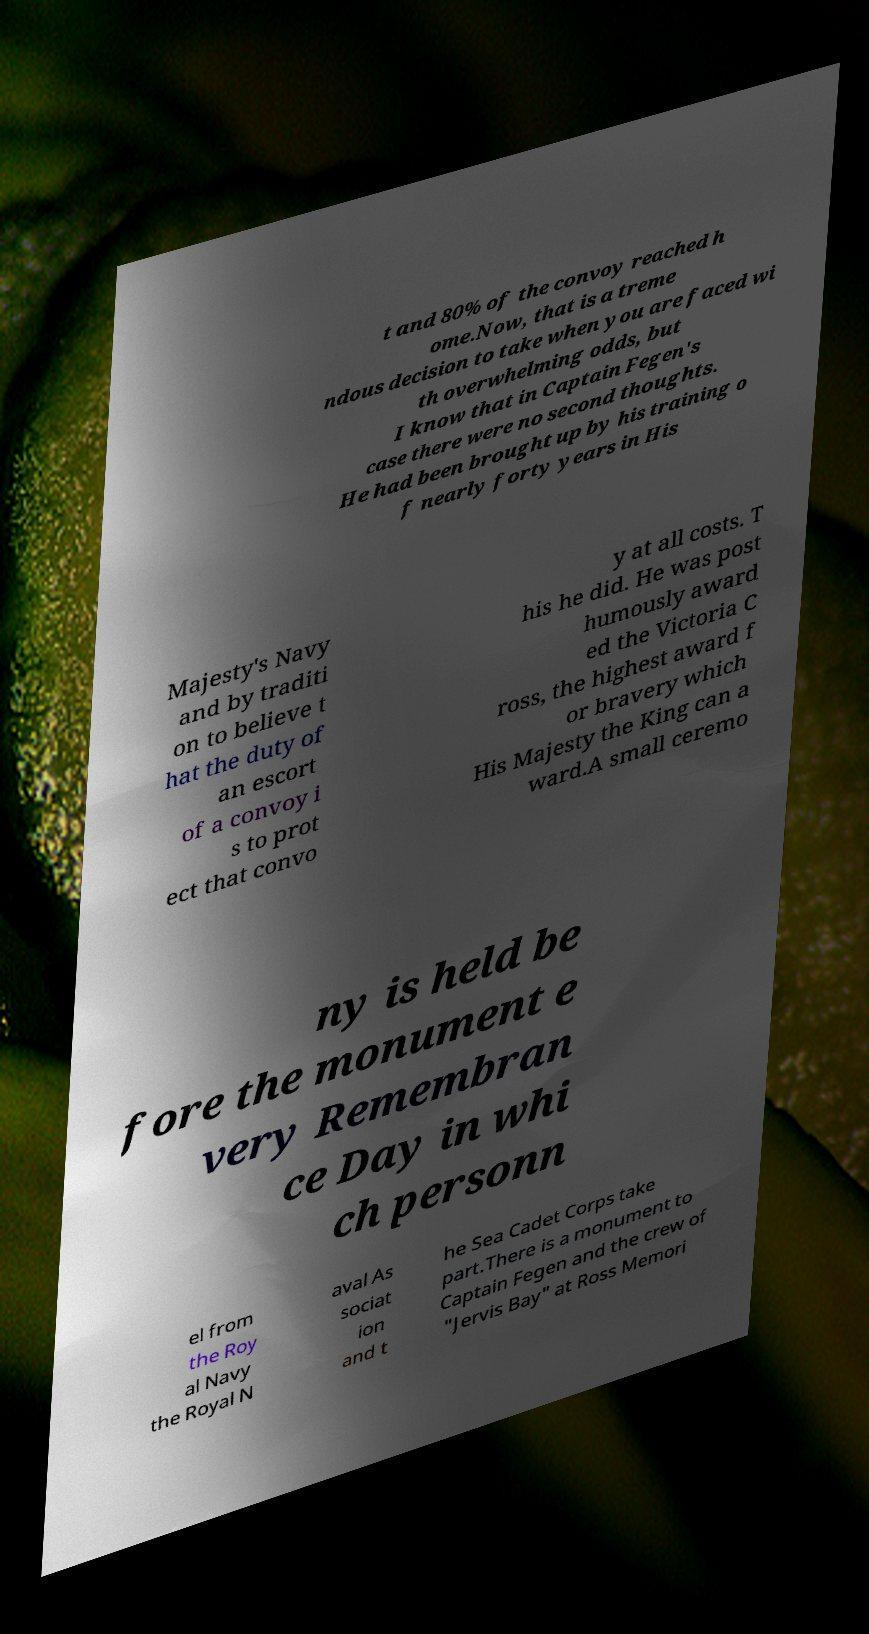What messages or text are displayed in this image? I need them in a readable, typed format. t and 80% of the convoy reached h ome.Now, that is a treme ndous decision to take when you are faced wi th overwhelming odds, but I know that in Captain Fegen's case there were no second thoughts. He had been brought up by his training o f nearly forty years in His Majesty's Navy and by traditi on to believe t hat the duty of an escort of a convoy i s to prot ect that convo y at all costs. T his he did. He was post humously award ed the Victoria C ross, the highest award f or bravery which His Majesty the King can a ward.A small ceremo ny is held be fore the monument e very Remembran ce Day in whi ch personn el from the Roy al Navy the Royal N aval As sociat ion and t he Sea Cadet Corps take part.There is a monument to Captain Fegen and the crew of "Jervis Bay" at Ross Memori 